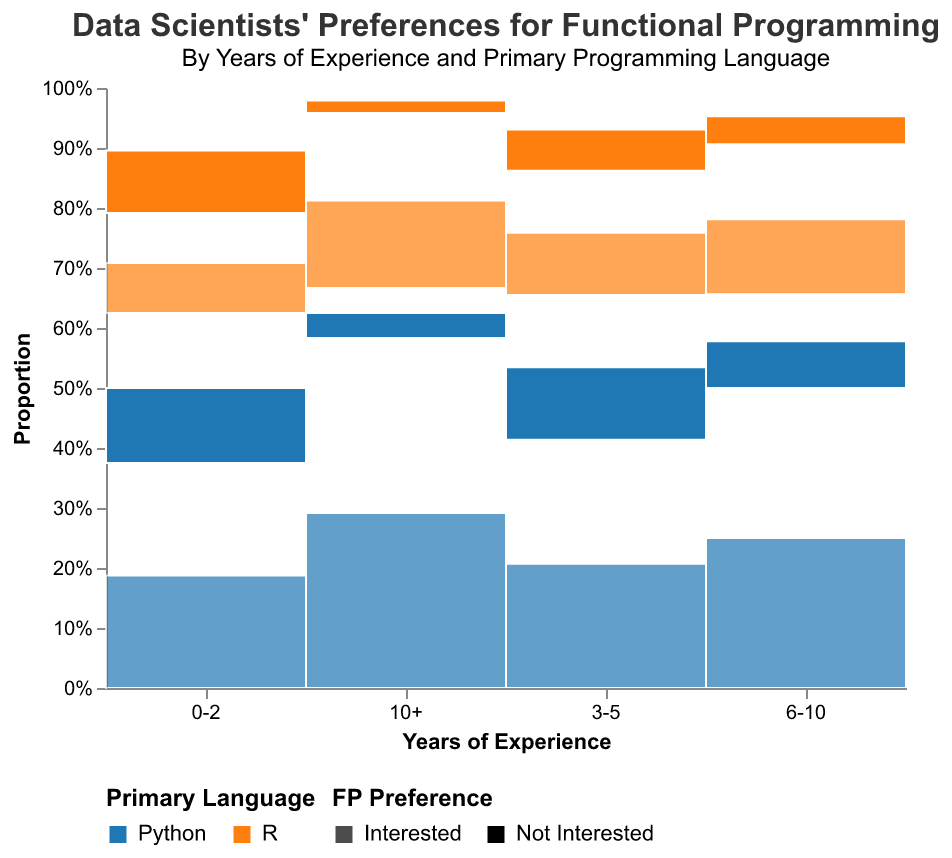What is the title of the plot? The title is displayed at the top of the plot. It reads "Data Scientists' Preferences for Functional Programming" with a subtitle "By Years of Experience and Primary Programming Language"
Answer: Data Scientists' Preferences for Functional Programming Which group has the highest count of people interested in functional programming? The tallest bar among the interested category is for data scientists with 6-10 years of experience using Python, represented by the tallest segment in the 'Interested' section for this group.
Answer: Data scientists with 6-10 years of experience using Python How does the preference for functional programming (FP) for data scientists with 0-2 years of experience split between Python and R users? Look at the '0-2' experience category. For Python, the interested and not interested counts are 45 and 30, respectively. For R, the counts are 20 and 25.
Answer: Python: 45 Interested / 30 Not Interested; R: 20 Interested / 25 Not Interested What is the total count of data scientists with 3-5 years of experience who are not interested in functional programming, across both languages? For data scientists with 3-5 years of experience, the 'Not Interested' counts are 35 (Python) and 20 (R). Adding these gives us 55.
Answer: 55 Which primary language shows a higher relative interest in functional programming among those with more than 10 years of experience? For the 10+ years experience group, compare interested counts: 70 (Python) vs. 35 (R). Both counts should also be compared using the respective proportions within their groups. Python has a higher absolute count.
Answer: Python What is the combined count of data scientists who are interested in functional programming for those with 6-10 years of experience across both languages? For the 6-10 experience category, the interested counts are 80 (Python) and 40 (R). Adding these gives us 120.
Answer: 120 Which experience group shows the highest proportion of users not interested in functional programming? Assess each experience group; the group with the highest number of 'Not Interested' counts and also consider the total for that group. 0-2 years experience in R has the highest proportions when counting only the dislike partition and their respective axes proportions.
Answer: 0-2 years in R How does interest in functional programming differ between Python and R users for the 6-10 years of experience category? Compare 'Interested' and 'Not Interested' proportions for users within the 6-10 years category by comparing the bar heights. Interested counts are 80 (Python) vs. 40 (R), and not interested counts are 25 (Python) vs. 15 (R).
Answer: Python: 80 Interested / 25 Not Interested; R: 40 Interested / 15 Not Interested 